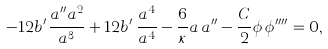Convert formula to latex. <formula><loc_0><loc_0><loc_500><loc_500>- 1 2 b ^ { \prime } \frac { a ^ { \prime \prime } a ^ { 2 } } { a ^ { 3 } } + 1 2 b ^ { \prime } \, \frac { a ^ { 4 } } { a ^ { 4 } } - \frac { 6 } { \kappa } a \, a ^ { \prime \prime } - \frac { C } { 2 } \phi \, \phi ^ { \prime \prime \prime \prime } = 0 ,</formula> 